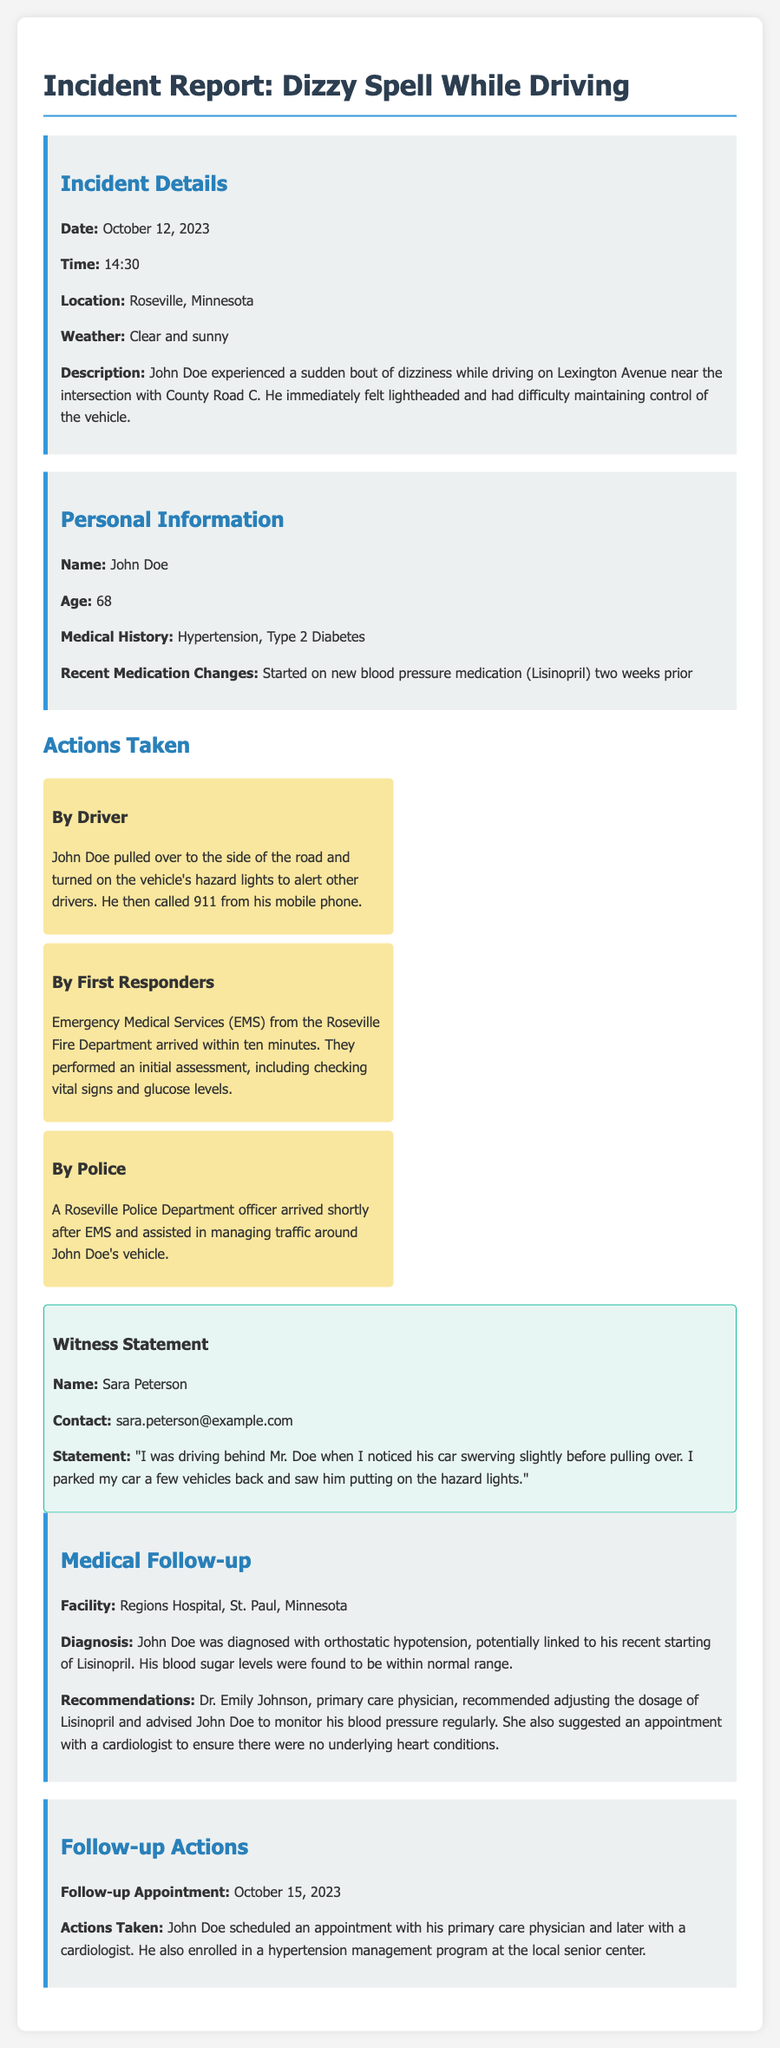what date did the incident occur? The date of the incident is stated clearly at the beginning of the document.
Answer: October 12, 2023 who is the driver involved in the incident? The document includes the name of the person who experienced the dizzy spell.
Answer: John Doe what was the weather like during the incident? The weather conditions at the time of the incident are specified in the document.
Answer: Clear and sunny what diagnosis was given to John Doe? The diagnosis is mentioned in the medical follow-up section of the report.
Answer: Orthostatic hypotension what emergency service arrived at the scene? The document specifies which emergency service responded to the incident.
Answer: Emergency Medical Services (EMS) what medication change did John Doe experience recently? The text describes a specific change in John's medication history before the incident.
Answer: Started on new blood pressure medication (Lisinopril) how long did it take for EMS to arrive at the scene? The response time of the EMS is provided in the actions taken section.
Answer: Within ten minutes what is one medical recommendation given to John Doe? The recommendations from the primary care physician are listed after the diagnosis.
Answer: Adjusting the dosage of Lisinopril what follow-up appointment was scheduled after the incident? The specific follow-up appointment date is detailed in the follow-up actions section.
Answer: October 15, 2023 